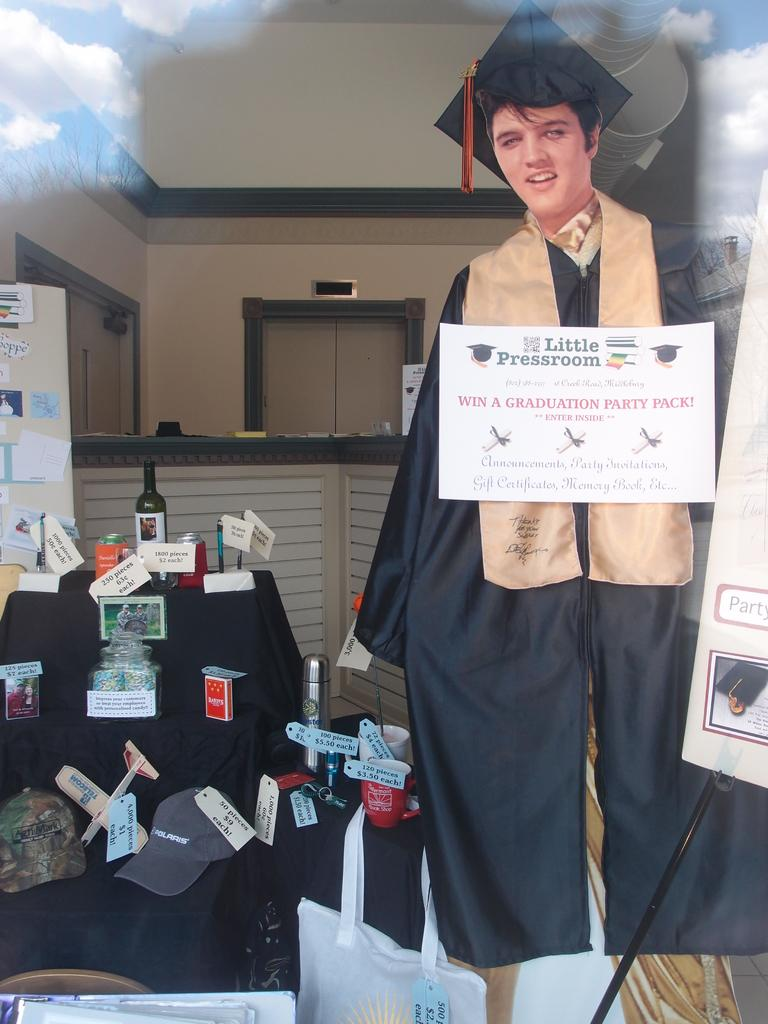Who is present in the image? There is a man in the image. What is the man doing in the image? The man is standing in the image. What is the man wearing in the image? The man is wearing a graduation gown in the image. What piece of furniture is visible in the image? There is a sofa in the image. What is on the sofa in the image? There are items on the sofa in the image. What is behind the man in the image? There is a wall behind the man in the image. What type of treatment is the man receiving from his uncle in the image? There is no uncle present in the image, and the man is not receiving any treatment. What is the man writing on the sofa in the image? There is no writing activity depicted in the image; the man is simply standing and wearing a graduation gown. 